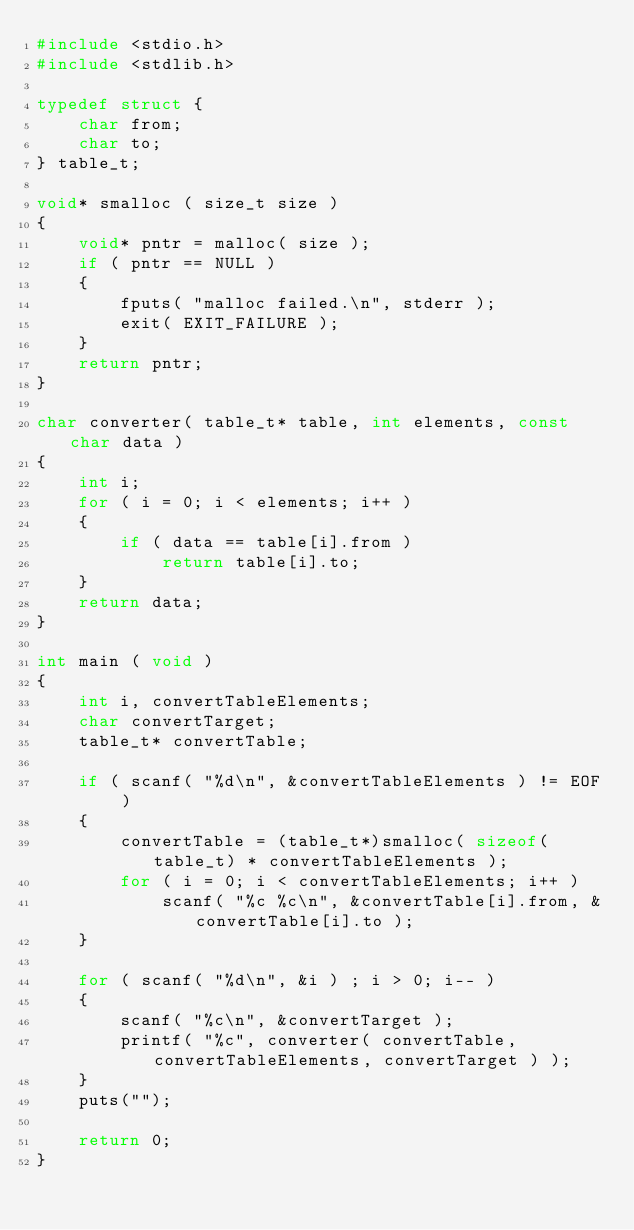<code> <loc_0><loc_0><loc_500><loc_500><_C_>#include <stdio.h>
#include <stdlib.h>

typedef struct {
    char from;
    char to;
} table_t;

void* smalloc ( size_t size )
{
    void* pntr = malloc( size );
    if ( pntr == NULL )
    {
        fputs( "malloc failed.\n", stderr );
        exit( EXIT_FAILURE );
    }
    return pntr;
}

char converter( table_t* table, int elements, const char data )
{
    int i;
    for ( i = 0; i < elements; i++ )
    {
        if ( data == table[i].from )
            return table[i].to;
    }
    return data;
}

int main ( void )
{
    int i, convertTableElements;
    char convertTarget;
    table_t* convertTable;

    if ( scanf( "%d\n", &convertTableElements ) != EOF )
    {
        convertTable = (table_t*)smalloc( sizeof(table_t) * convertTableElements );
        for ( i = 0; i < convertTableElements; i++ )
            scanf( "%c %c\n", &convertTable[i].from, &convertTable[i].to );
    }

    for ( scanf( "%d\n", &i ) ; i > 0; i-- )
    {
        scanf( "%c\n", &convertTarget );
        printf( "%c", converter( convertTable, convertTableElements, convertTarget ) );
    }
    puts("");

    return 0;
}</code> 